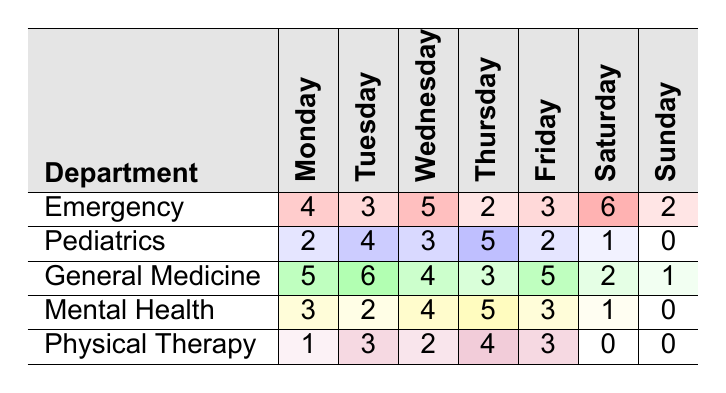What are the volunteer hours logged in the Emergency department on Thursday? In the table, the Emergency department shows 2 volunteer hours logged on Thursday.
Answer: 2 Which department had the highest number of volunteer hours logged on Saturday? The General Medicine department had the highest volunteer hours logged on Saturday, which is 2.
Answer: 2 How many total volunteer hours were logged by the Pediatrics department over the week? Summing up the hours for Pediatrics: 2 + 4 + 3 + 5 + 2 + 1 + 0 = 17.
Answer: 17 In which department did volunteers log 0 hours on Sunday? The Pediatrics and Physical Therapy departments logged 0 hours on Sunday.
Answer: Pediatrics and Physical Therapy What is the average number of volunteer hours logged by the Mental Health department across all days? The Mental Health department had hours [3, 2, 4, 5, 3, 1, 0]. Summing these gives 18 hours, and dividing by 7 (days) results in an average of 2.57 (approximately).
Answer: 2.57 Did the Physical Therapy department log more hours on Friday than on Thursday? The Physical Therapy department logged 3 hours on Friday and 4 hours on Thursday. Since 3 is less than 4, this statement is false.
Answer: No What is the difference in total volunteer hours logged between the General Medicine and Emergency departments? Adding the hours for General Medicine: 5 + 6 + 4 + 3 + 5 + 2 + 1 = 26, and for Emergency: 4 + 3 + 5 + 2 + 3 + 6 + 2 = 25. The difference is 26 - 25 = 1.
Answer: 1 Which day had the least total volunteer hours across all departments? Adding all volunteer hours for each day: Monday (4 + 2 + 5 + 3 + 1 = 15), Tuesday (3 + 4 + 6 + 2 + 3 = 18), Wednesday (5 + 3 + 4 + 4 + 2 = 18), Thursday (2 + 5 + 3 + 5 + 4 = 19), Friday (3 + 2 + 5 + 3 + 3 = 16), Saturday (6 + 1 + 2 + 1 + 0 = 10), Sunday (2 + 0 + 1 + 0 + 0 = 3). The least is Sunday with 3 hours.
Answer: Sunday How many departments logged 4 or more volunteer hours on Wednesday? The departments logged hours on Wednesday as follows: Emergency (5), Pediatrics (3), General Medicine (4), Mental Health (4), Physical Therapy (2). Thus, 4 departments logged 4 or more hours (Emergency, General Medicine, Mental Health).
Answer: 3 Was there a day where all departments logged more than 4 hours? Checking each day: No day had all departments log more than 4 hours as maximum logs are below that.
Answer: No 